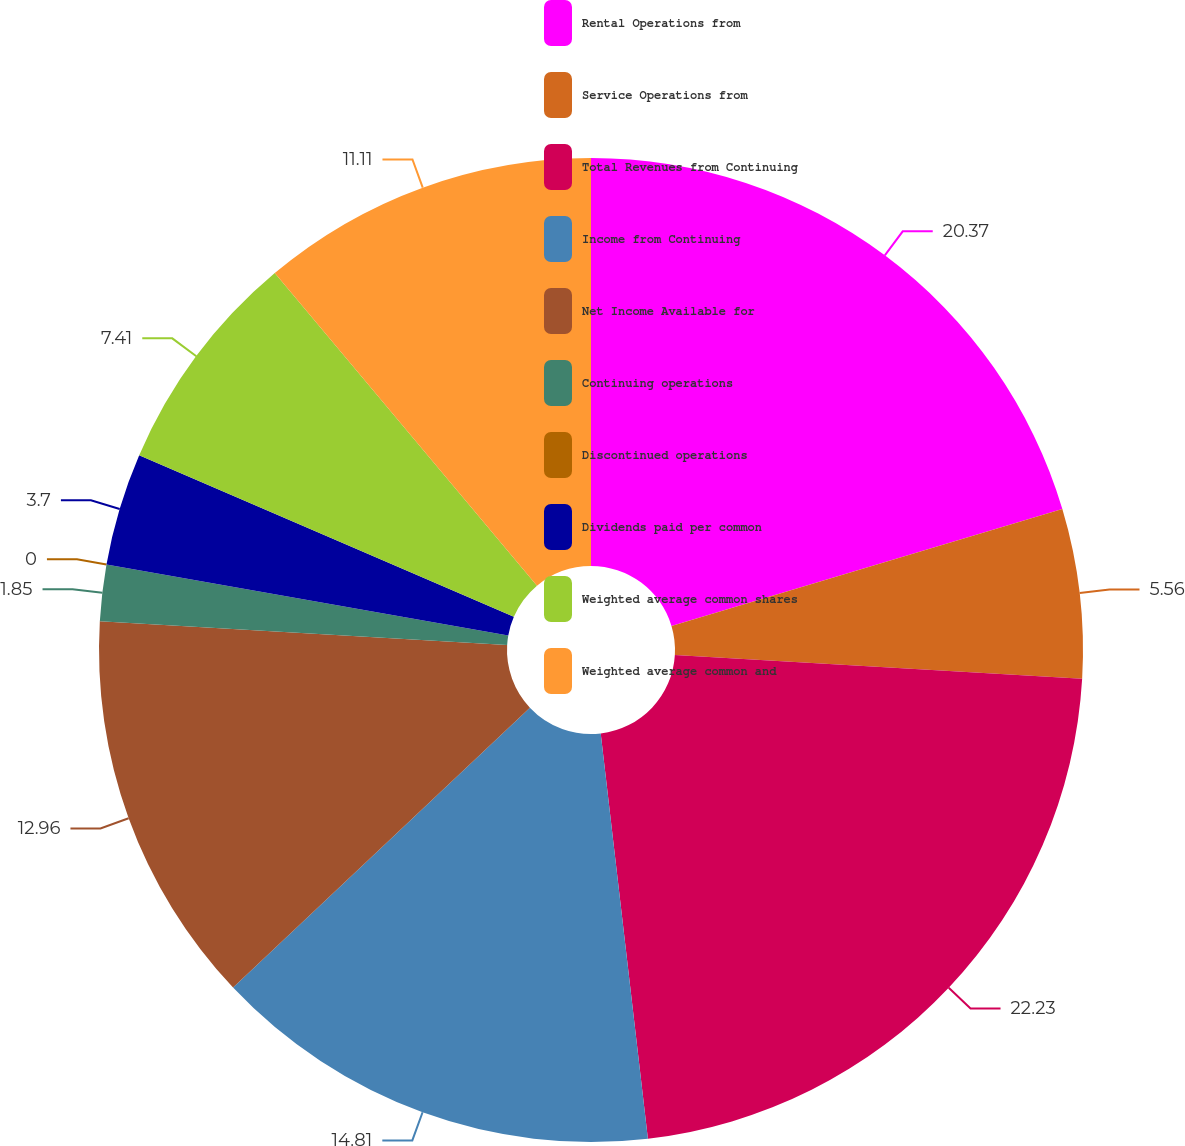<chart> <loc_0><loc_0><loc_500><loc_500><pie_chart><fcel>Rental Operations from<fcel>Service Operations from<fcel>Total Revenues from Continuing<fcel>Income from Continuing<fcel>Net Income Available for<fcel>Continuing operations<fcel>Discontinued operations<fcel>Dividends paid per common<fcel>Weighted average common shares<fcel>Weighted average common and<nl><fcel>20.37%<fcel>5.56%<fcel>22.22%<fcel>14.81%<fcel>12.96%<fcel>1.85%<fcel>0.0%<fcel>3.7%<fcel>7.41%<fcel>11.11%<nl></chart> 